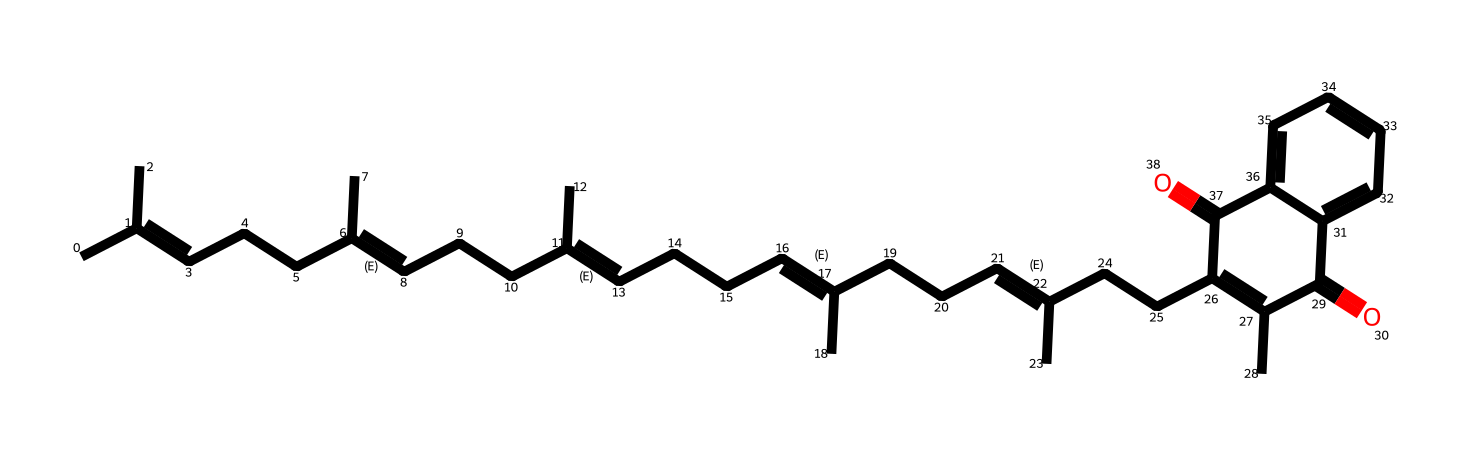What is the name of this chemical? The chemical structure corresponds to a specific compound known as vitamin K2, or menaquinone. This is based on the unique arrangement of carbon atoms and specific functional groups present in its SMILES representation.
Answer: vitamin K2 (menaquinone) How many carbon atoms are in the structure? By analyzing the SMILES notation, we note the presence of multiple 'C' characters representing carbon atoms. Counting these shows that there are a total of 27 carbon atoms in the structure.
Answer: 27 What type of functional groups are present in this molecule? Inspecting the structure reveals the presence of a ketone functional group (indicated by the carbonyl groups) and possibly other unsaturation points (double bonds). These groups are characteristic of many vitamins, including vitamin K2.
Answer: ketones How many double bonds are in the vitamin K2 structure? By looking at the connections between carbon atoms in the SMILES, we can identify areas where double bonds are indicated (noted by the specific structural notation). In this case, we can count a total of 6 double bonds present in the structure.
Answer: 6 What does the presence of unsaturation imply about the molecule? The presence of unsaturated bonds (double bonds) in the structure indicates that the molecule has potential for increased reactivity compared to saturated molecules. This reactivity is significant in biological processes for vitamins and can influence their function.
Answer: increased reactivity Is this vitamin fat-soluble or water-soluble? Based on the chemical structure, particularly the long carbon chain and the presence of double bonds, it is implied that vitamin K2 is fat-soluble, meaning it dissolves in fats and oils rather than water.
Answer: fat-soluble 